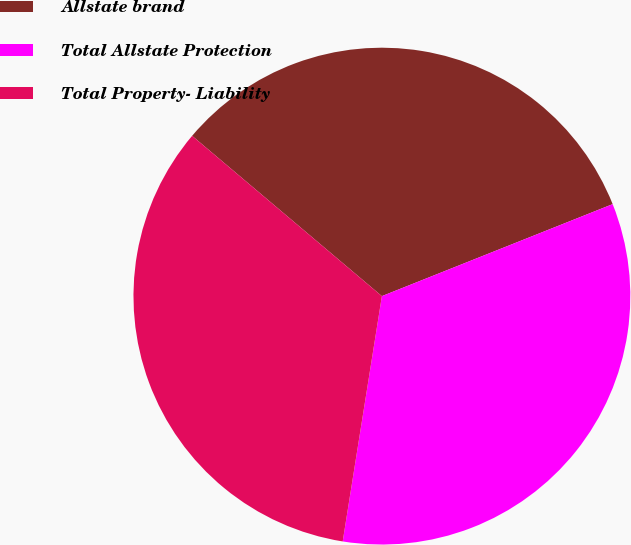<chart> <loc_0><loc_0><loc_500><loc_500><pie_chart><fcel>Allstate brand<fcel>Total Allstate Protection<fcel>Total Property- Liability<nl><fcel>32.8%<fcel>33.56%<fcel>33.64%<nl></chart> 